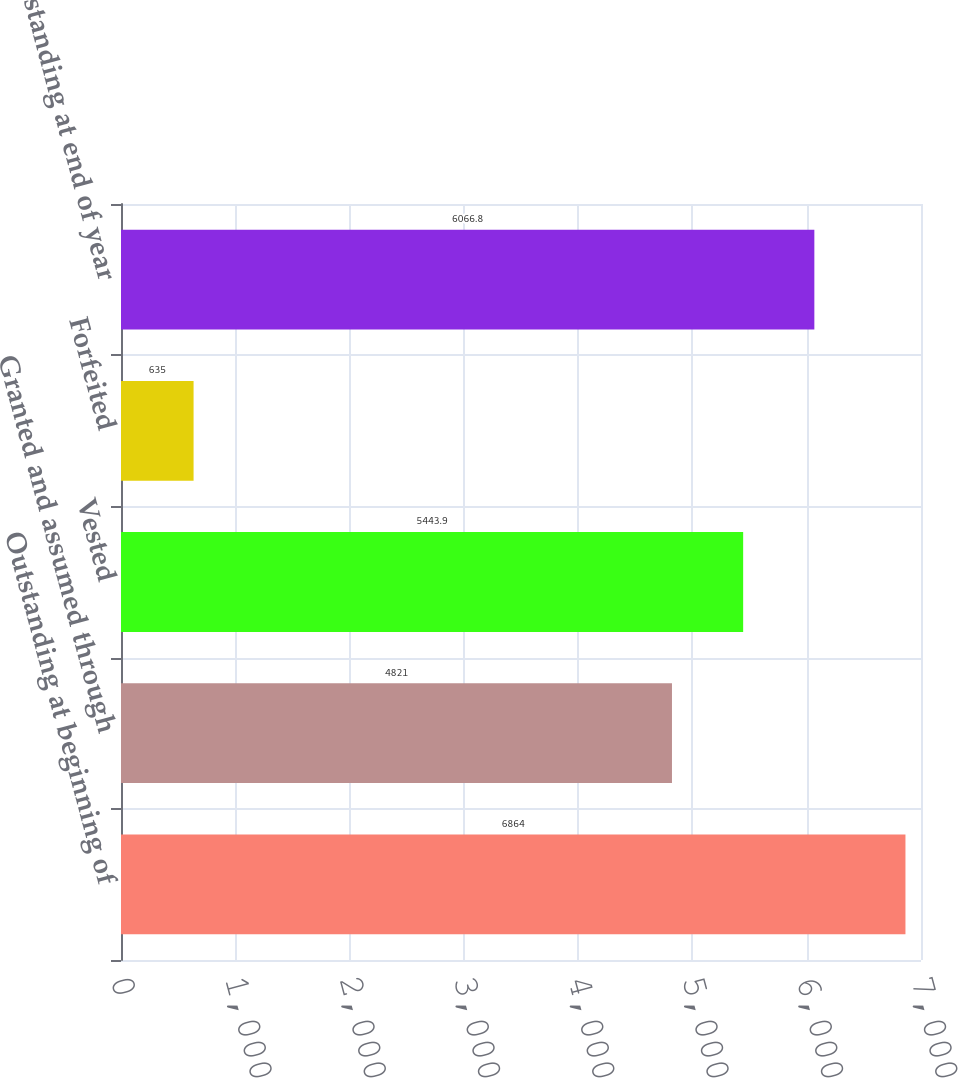Convert chart to OTSL. <chart><loc_0><loc_0><loc_500><loc_500><bar_chart><fcel>Outstanding at beginning of<fcel>Granted and assumed through<fcel>Vested<fcel>Forfeited<fcel>Outstanding at end of year<nl><fcel>6864<fcel>4821<fcel>5443.9<fcel>635<fcel>6066.8<nl></chart> 